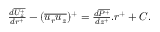<formula> <loc_0><loc_0><loc_500><loc_500>\begin{array} { r } { \frac { d \overline { { U _ { z } ^ { + } } } } { d r ^ { + } } - ( \overline { { u _ { r } u _ { z } } } ) ^ { + } = \frac { d \overline { { P ^ { + } } } } { d z ^ { + } } . r ^ { + } + C . } \end{array}</formula> 